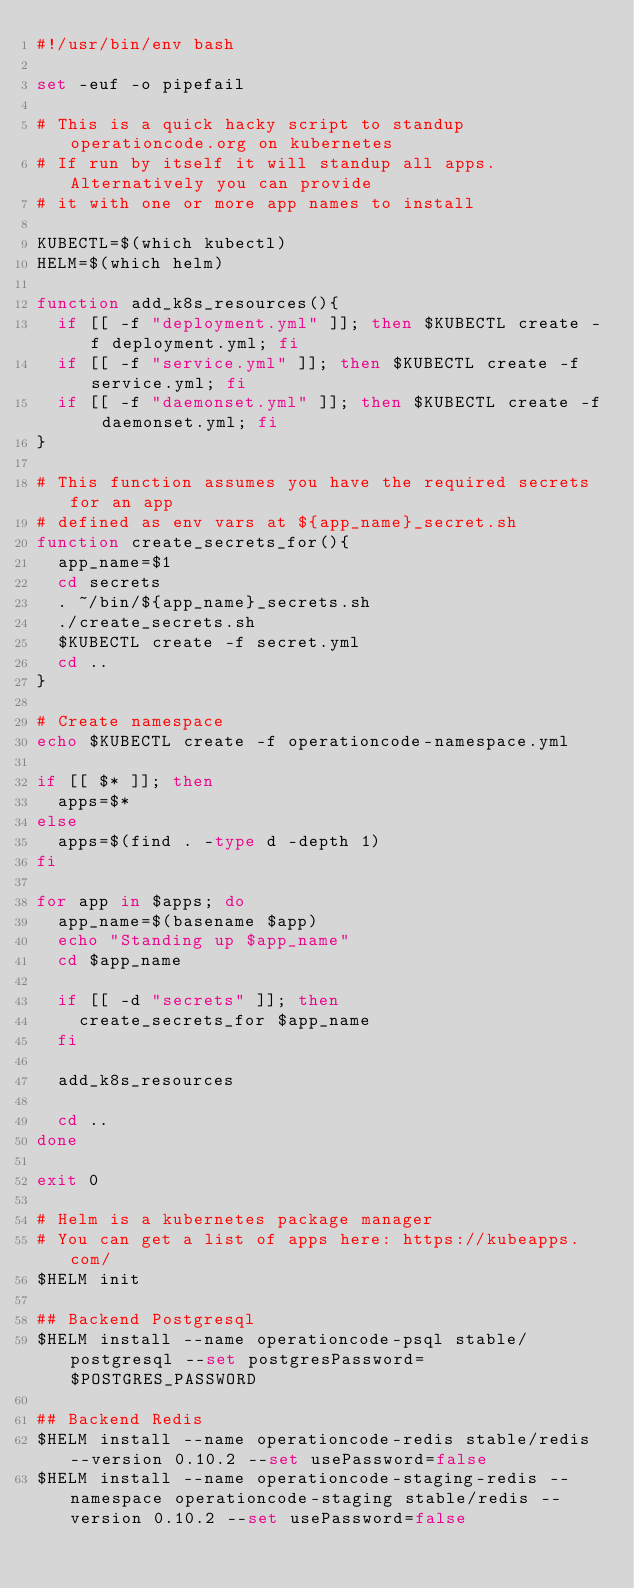Convert code to text. <code><loc_0><loc_0><loc_500><loc_500><_Bash_>#!/usr/bin/env bash

set -euf -o pipefail

# This is a quick hacky script to standup operationcode.org on kubernetes
# If run by itself it will standup all apps. Alternatively you can provide
# it with one or more app names to install

KUBECTL=$(which kubectl)
HELM=$(which helm)

function add_k8s_resources(){
  if [[ -f "deployment.yml" ]]; then $KUBECTL create -f deployment.yml; fi
  if [[ -f "service.yml" ]]; then $KUBECTL create -f service.yml; fi
  if [[ -f "daemonset.yml" ]]; then $KUBECTL create -f daemonset.yml; fi
}

# This function assumes you have the required secrets for an app
# defined as env vars at ${app_name}_secret.sh
function create_secrets_for(){
  app_name=$1
  cd secrets
  . ~/bin/${app_name}_secrets.sh
  ./create_secrets.sh
  $KUBECTL create -f secret.yml
  cd ..
}

# Create namespace
echo $KUBECTL create -f operationcode-namespace.yml

if [[ $* ]]; then
  apps=$*
else
  apps=$(find . -type d -depth 1)
fi

for app in $apps; do
  app_name=$(basename $app)
  echo "Standing up $app_name"
  cd $app_name

  if [[ -d "secrets" ]]; then
    create_secrets_for $app_name
  fi

  add_k8s_resources

  cd ..
done

exit 0

# Helm is a kubernetes package manager
# You can get a list of apps here: https://kubeapps.com/
$HELM init

## Backend Postgresql
$HELM install --name operationcode-psql stable/postgresql --set postgresPassword=$POSTGRES_PASSWORD

## Backend Redis
$HELM install --name operationcode-redis stable/redis --version 0.10.2 --set usePassword=false
$HELM install --name operationcode-staging-redis --namespace operationcode-staging stable/redis --version 0.10.2 --set usePassword=false
</code> 